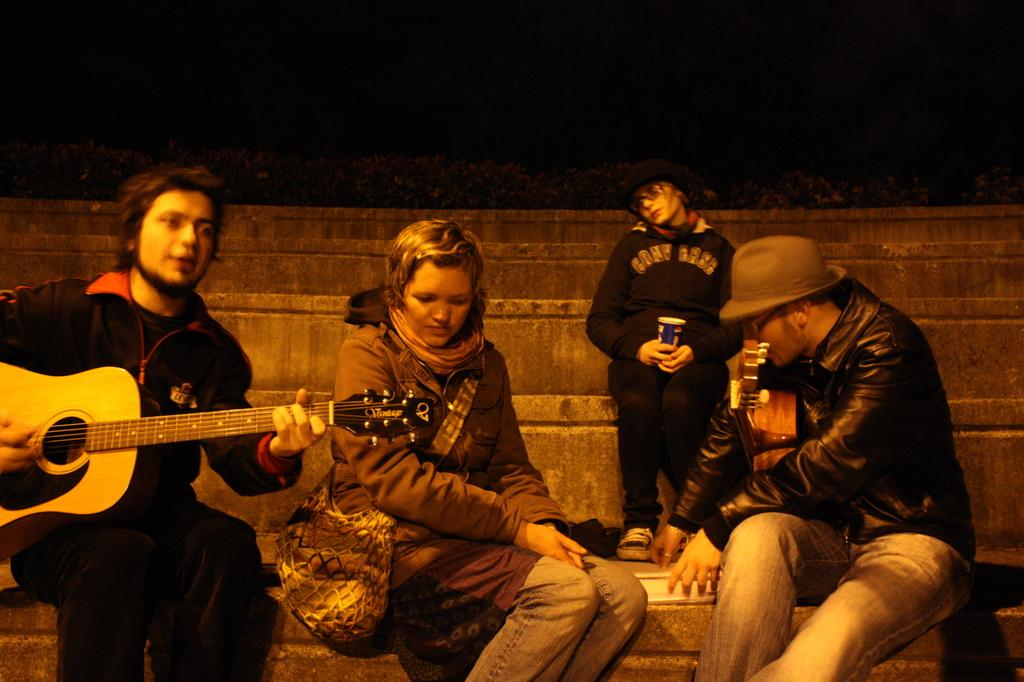How many people are present in the image? There are four people in the image. What is one person doing in the image? One person is playing a guitar. How many deer can be seen in the image? There are no deer present in the image. What type of produce is being held by one of the people in the image? There is no produce visible in the image. 